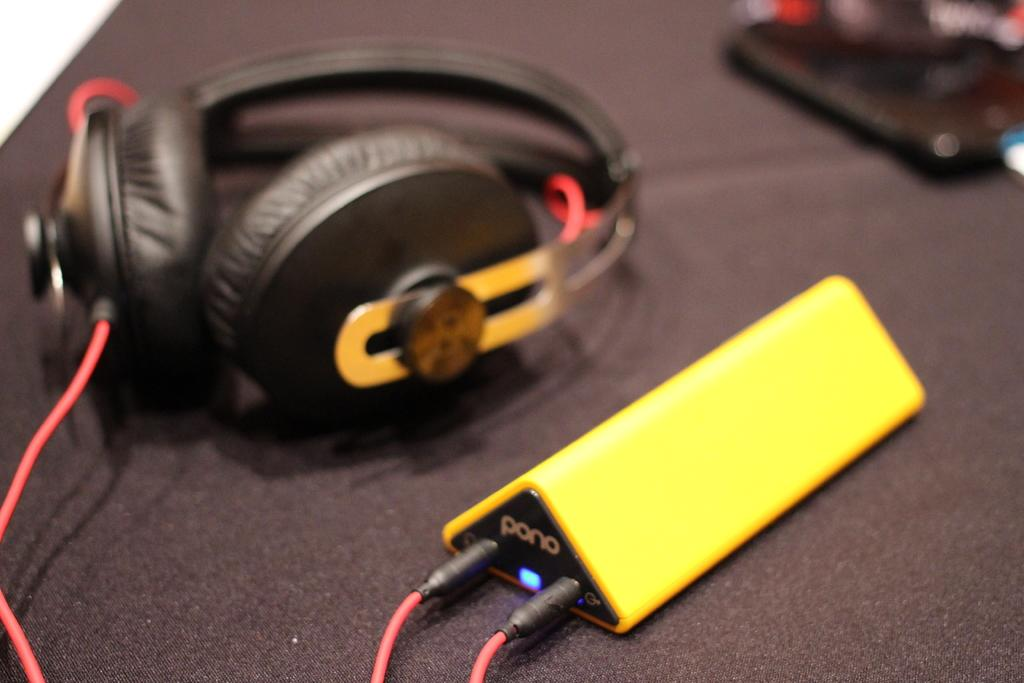What device is visible in the image? There is a headset in the image. What is the headset connected to? There is a digital music player in the image. Can you describe the background of the image? The background of the image is blurry. How many mice are visible on the earth in the image? There are no mice or earth present in the image. Who is the friend that can be seen in the image? There is no friend visible in the image. 